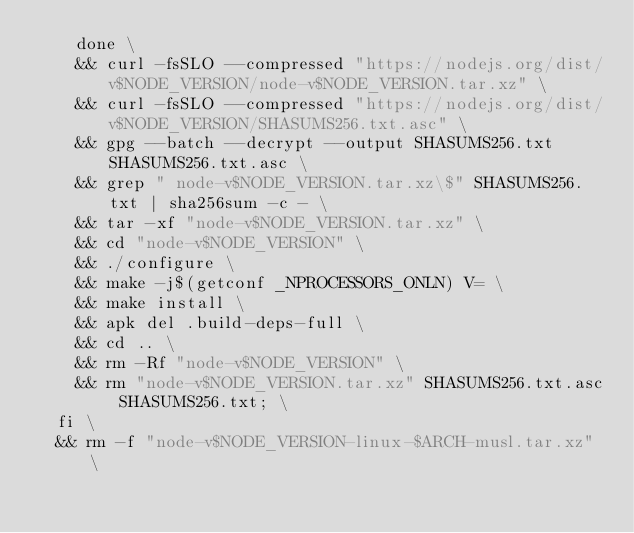Convert code to text. <code><loc_0><loc_0><loc_500><loc_500><_Dockerfile_>    done \
    && curl -fsSLO --compressed "https://nodejs.org/dist/v$NODE_VERSION/node-v$NODE_VERSION.tar.xz" \
    && curl -fsSLO --compressed "https://nodejs.org/dist/v$NODE_VERSION/SHASUMS256.txt.asc" \
    && gpg --batch --decrypt --output SHASUMS256.txt SHASUMS256.txt.asc \
    && grep " node-v$NODE_VERSION.tar.xz\$" SHASUMS256.txt | sha256sum -c - \
    && tar -xf "node-v$NODE_VERSION.tar.xz" \
    && cd "node-v$NODE_VERSION" \
    && ./configure \
    && make -j$(getconf _NPROCESSORS_ONLN) V= \
    && make install \
    && apk del .build-deps-full \
    && cd .. \
    && rm -Rf "node-v$NODE_VERSION" \
    && rm "node-v$NODE_VERSION.tar.xz" SHASUMS256.txt.asc SHASUMS256.txt; \
  fi \
  && rm -f "node-v$NODE_VERSION-linux-$ARCH-musl.tar.xz" \</code> 